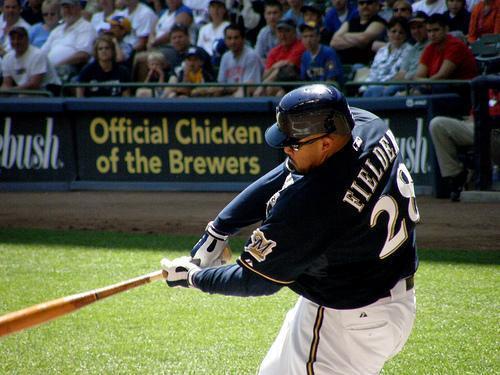How many baseball bats are in the picture?
Give a very brief answer. 1. How many people can you see?
Give a very brief answer. 6. 